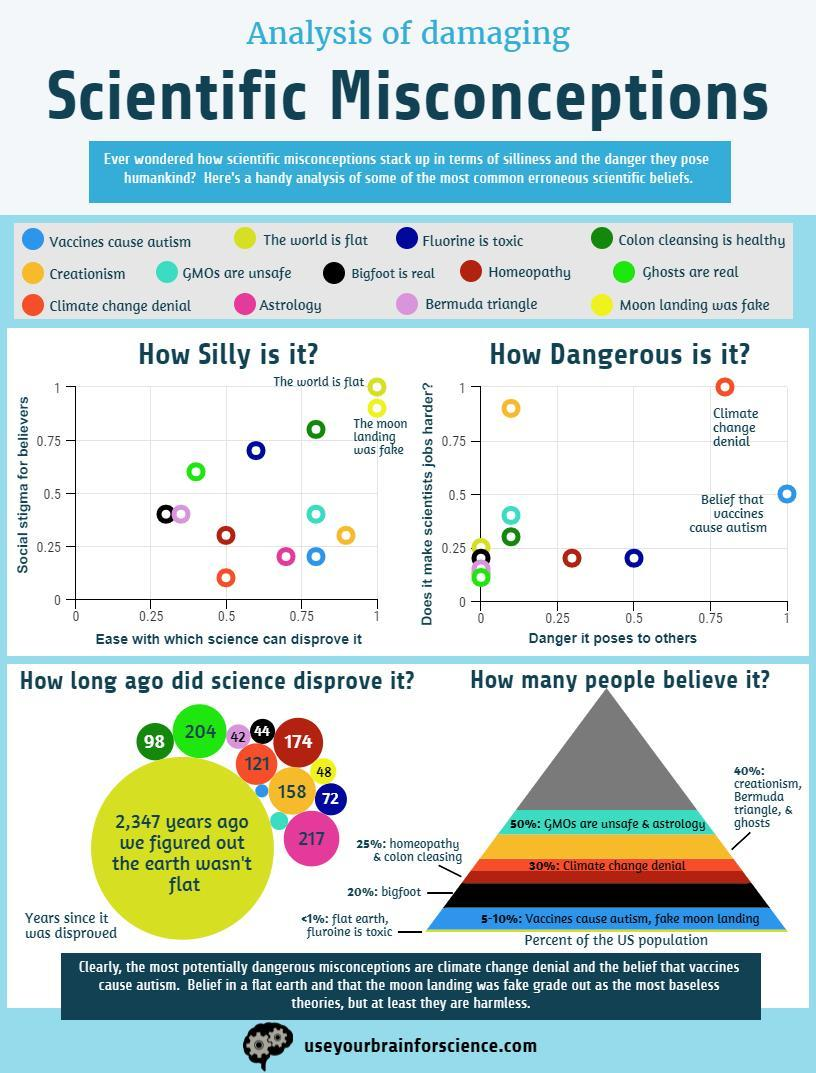Which scientific misconception ranks lowest in social stigma and is not easy to disprove  ?
Answer the question with a short phrase. Big foot is real How many scientific misconceptions pose the least amount of threat to others? 4 How many scientific misconceptions fall below the 0.5 scale in the risk it causes to others? 8 Which scientific misconception ranks third in social stigmas ? Colon cleansing is healthy Which scientific misconception scores third highest in terms of the danger it poses? Fluorine is toxic 